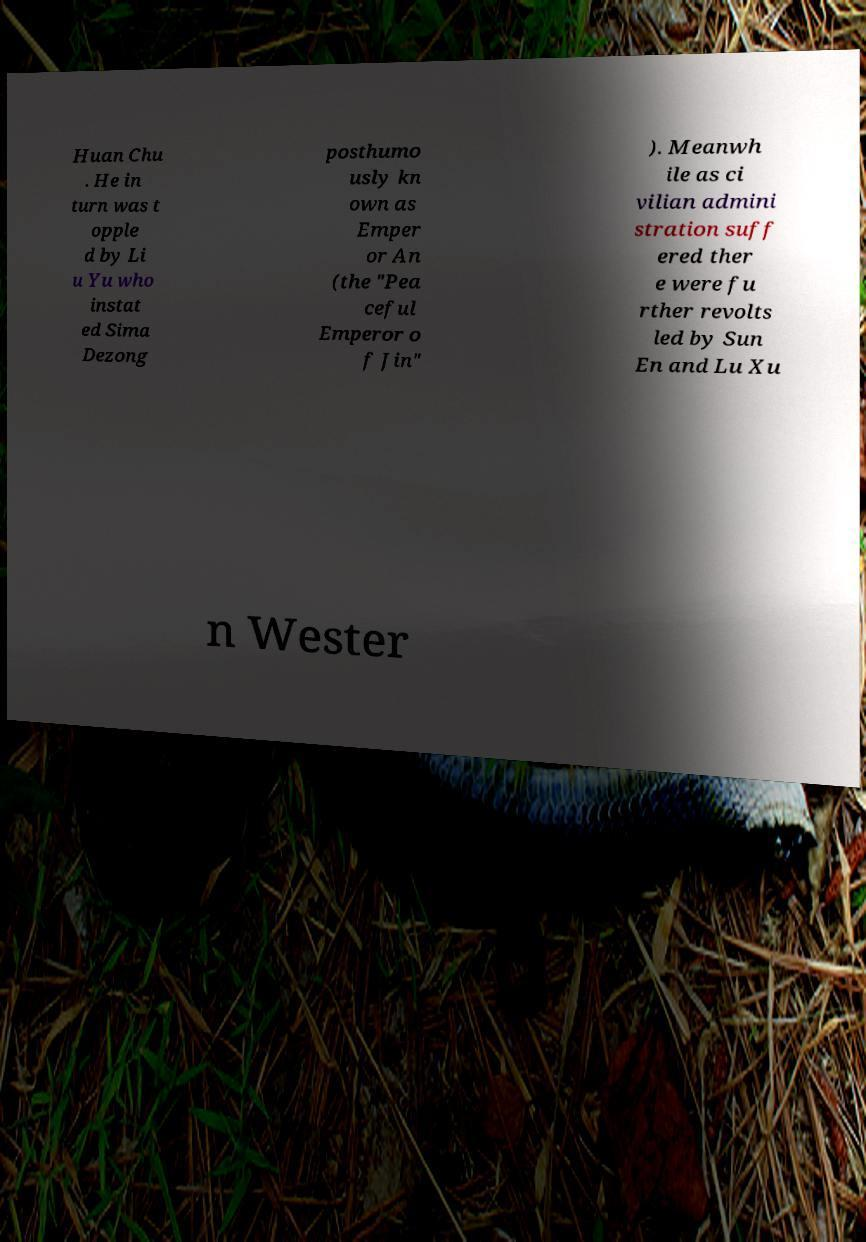Can you read and provide the text displayed in the image?This photo seems to have some interesting text. Can you extract and type it out for me? Huan Chu . He in turn was t opple d by Li u Yu who instat ed Sima Dezong posthumo usly kn own as Emper or An (the "Pea ceful Emperor o f Jin" ). Meanwh ile as ci vilian admini stration suff ered ther e were fu rther revolts led by Sun En and Lu Xu n Wester 